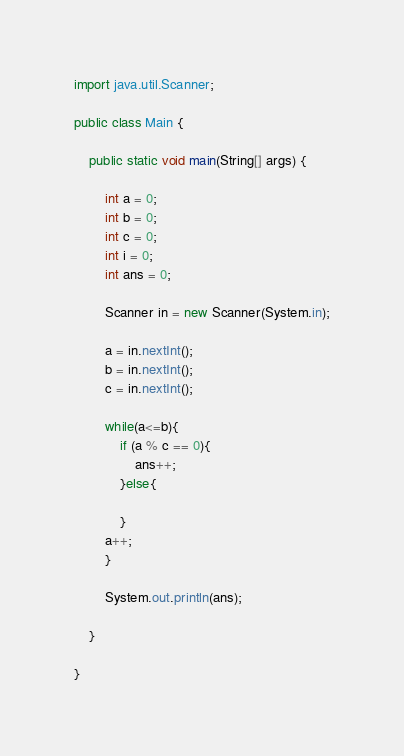<code> <loc_0><loc_0><loc_500><loc_500><_Java_>import java.util.Scanner;

public class Main {

	public static void main(String[] args) {

		int a = 0;
		int b = 0;
		int c = 0;
		int i = 0;
		int ans = 0;

		Scanner in = new Scanner(System.in);

		a = in.nextInt();
		b = in.nextInt();
		c = in.nextInt();

		while(a<=b){
			if (a % c == 0){
				ans++;
			}else{

			}
		a++;
		}

		System.out.println(ans);

	}

}</code> 